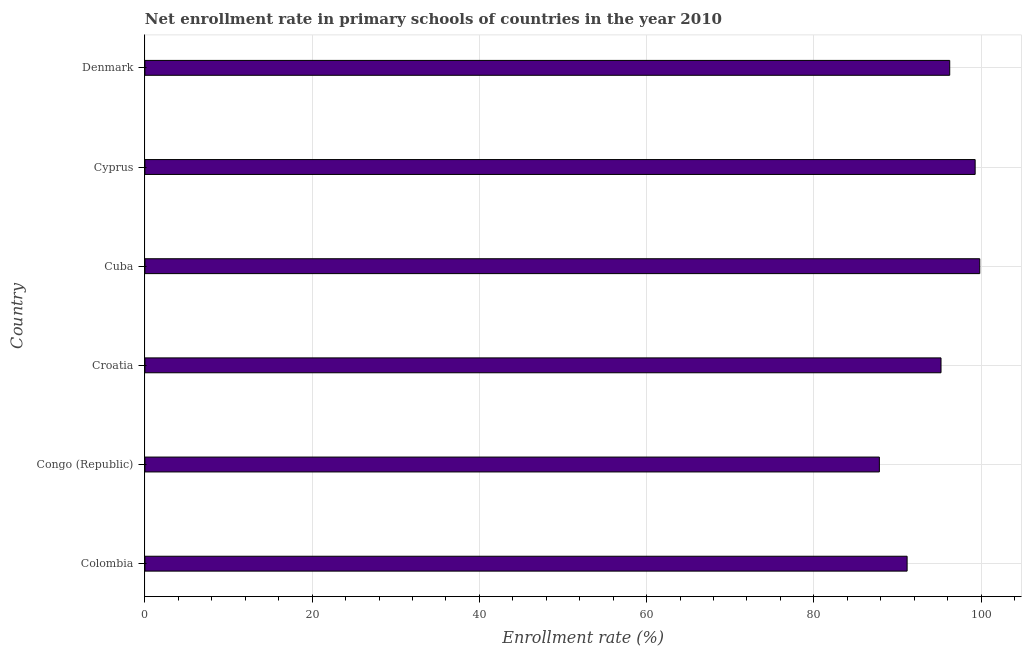Does the graph contain grids?
Your response must be concise. Yes. What is the title of the graph?
Your answer should be very brief. Net enrollment rate in primary schools of countries in the year 2010. What is the label or title of the X-axis?
Your response must be concise. Enrollment rate (%). What is the net enrollment rate in primary schools in Cuba?
Provide a short and direct response. 99.84. Across all countries, what is the maximum net enrollment rate in primary schools?
Make the answer very short. 99.84. Across all countries, what is the minimum net enrollment rate in primary schools?
Ensure brevity in your answer.  87.83. In which country was the net enrollment rate in primary schools maximum?
Your answer should be very brief. Cuba. In which country was the net enrollment rate in primary schools minimum?
Offer a terse response. Congo (Republic). What is the sum of the net enrollment rate in primary schools?
Provide a short and direct response. 569.55. What is the difference between the net enrollment rate in primary schools in Colombia and Croatia?
Make the answer very short. -4.05. What is the average net enrollment rate in primary schools per country?
Your response must be concise. 94.92. What is the median net enrollment rate in primary schools?
Offer a terse response. 95.72. What is the ratio of the net enrollment rate in primary schools in Croatia to that in Cuba?
Provide a short and direct response. 0.95. Is the net enrollment rate in primary schools in Congo (Republic) less than that in Cyprus?
Your answer should be compact. Yes. What is the difference between the highest and the second highest net enrollment rate in primary schools?
Keep it short and to the point. 0.55. What is the difference between the highest and the lowest net enrollment rate in primary schools?
Offer a terse response. 12. Are all the bars in the graph horizontal?
Offer a very short reply. Yes. What is the difference between two consecutive major ticks on the X-axis?
Provide a succinct answer. 20. What is the Enrollment rate (%) of Colombia?
Provide a succinct answer. 91.15. What is the Enrollment rate (%) of Congo (Republic)?
Provide a short and direct response. 87.83. What is the Enrollment rate (%) of Croatia?
Your answer should be compact. 95.2. What is the Enrollment rate (%) of Cuba?
Provide a short and direct response. 99.84. What is the Enrollment rate (%) in Cyprus?
Provide a succinct answer. 99.29. What is the Enrollment rate (%) of Denmark?
Provide a succinct answer. 96.24. What is the difference between the Enrollment rate (%) in Colombia and Congo (Republic)?
Keep it short and to the point. 3.32. What is the difference between the Enrollment rate (%) in Colombia and Croatia?
Provide a short and direct response. -4.05. What is the difference between the Enrollment rate (%) in Colombia and Cuba?
Your response must be concise. -8.69. What is the difference between the Enrollment rate (%) in Colombia and Cyprus?
Provide a succinct answer. -8.14. What is the difference between the Enrollment rate (%) in Colombia and Denmark?
Keep it short and to the point. -5.09. What is the difference between the Enrollment rate (%) in Congo (Republic) and Croatia?
Offer a terse response. -7.37. What is the difference between the Enrollment rate (%) in Congo (Republic) and Cuba?
Offer a terse response. -12. What is the difference between the Enrollment rate (%) in Congo (Republic) and Cyprus?
Your answer should be compact. -11.45. What is the difference between the Enrollment rate (%) in Congo (Republic) and Denmark?
Provide a succinct answer. -8.41. What is the difference between the Enrollment rate (%) in Croatia and Cuba?
Your response must be concise. -4.63. What is the difference between the Enrollment rate (%) in Croatia and Cyprus?
Your answer should be compact. -4.08. What is the difference between the Enrollment rate (%) in Croatia and Denmark?
Offer a terse response. -1.04. What is the difference between the Enrollment rate (%) in Cuba and Cyprus?
Make the answer very short. 0.55. What is the difference between the Enrollment rate (%) in Cuba and Denmark?
Your response must be concise. 3.59. What is the difference between the Enrollment rate (%) in Cyprus and Denmark?
Offer a very short reply. 3.04. What is the ratio of the Enrollment rate (%) in Colombia to that in Congo (Republic)?
Offer a very short reply. 1.04. What is the ratio of the Enrollment rate (%) in Colombia to that in Cyprus?
Provide a short and direct response. 0.92. What is the ratio of the Enrollment rate (%) in Colombia to that in Denmark?
Make the answer very short. 0.95. What is the ratio of the Enrollment rate (%) in Congo (Republic) to that in Croatia?
Make the answer very short. 0.92. What is the ratio of the Enrollment rate (%) in Congo (Republic) to that in Cyprus?
Your answer should be very brief. 0.89. What is the ratio of the Enrollment rate (%) in Congo (Republic) to that in Denmark?
Your answer should be compact. 0.91. What is the ratio of the Enrollment rate (%) in Croatia to that in Cuba?
Keep it short and to the point. 0.95. What is the ratio of the Enrollment rate (%) in Croatia to that in Cyprus?
Provide a short and direct response. 0.96. What is the ratio of the Enrollment rate (%) in Cuba to that in Denmark?
Your answer should be very brief. 1.04. What is the ratio of the Enrollment rate (%) in Cyprus to that in Denmark?
Offer a terse response. 1.03. 